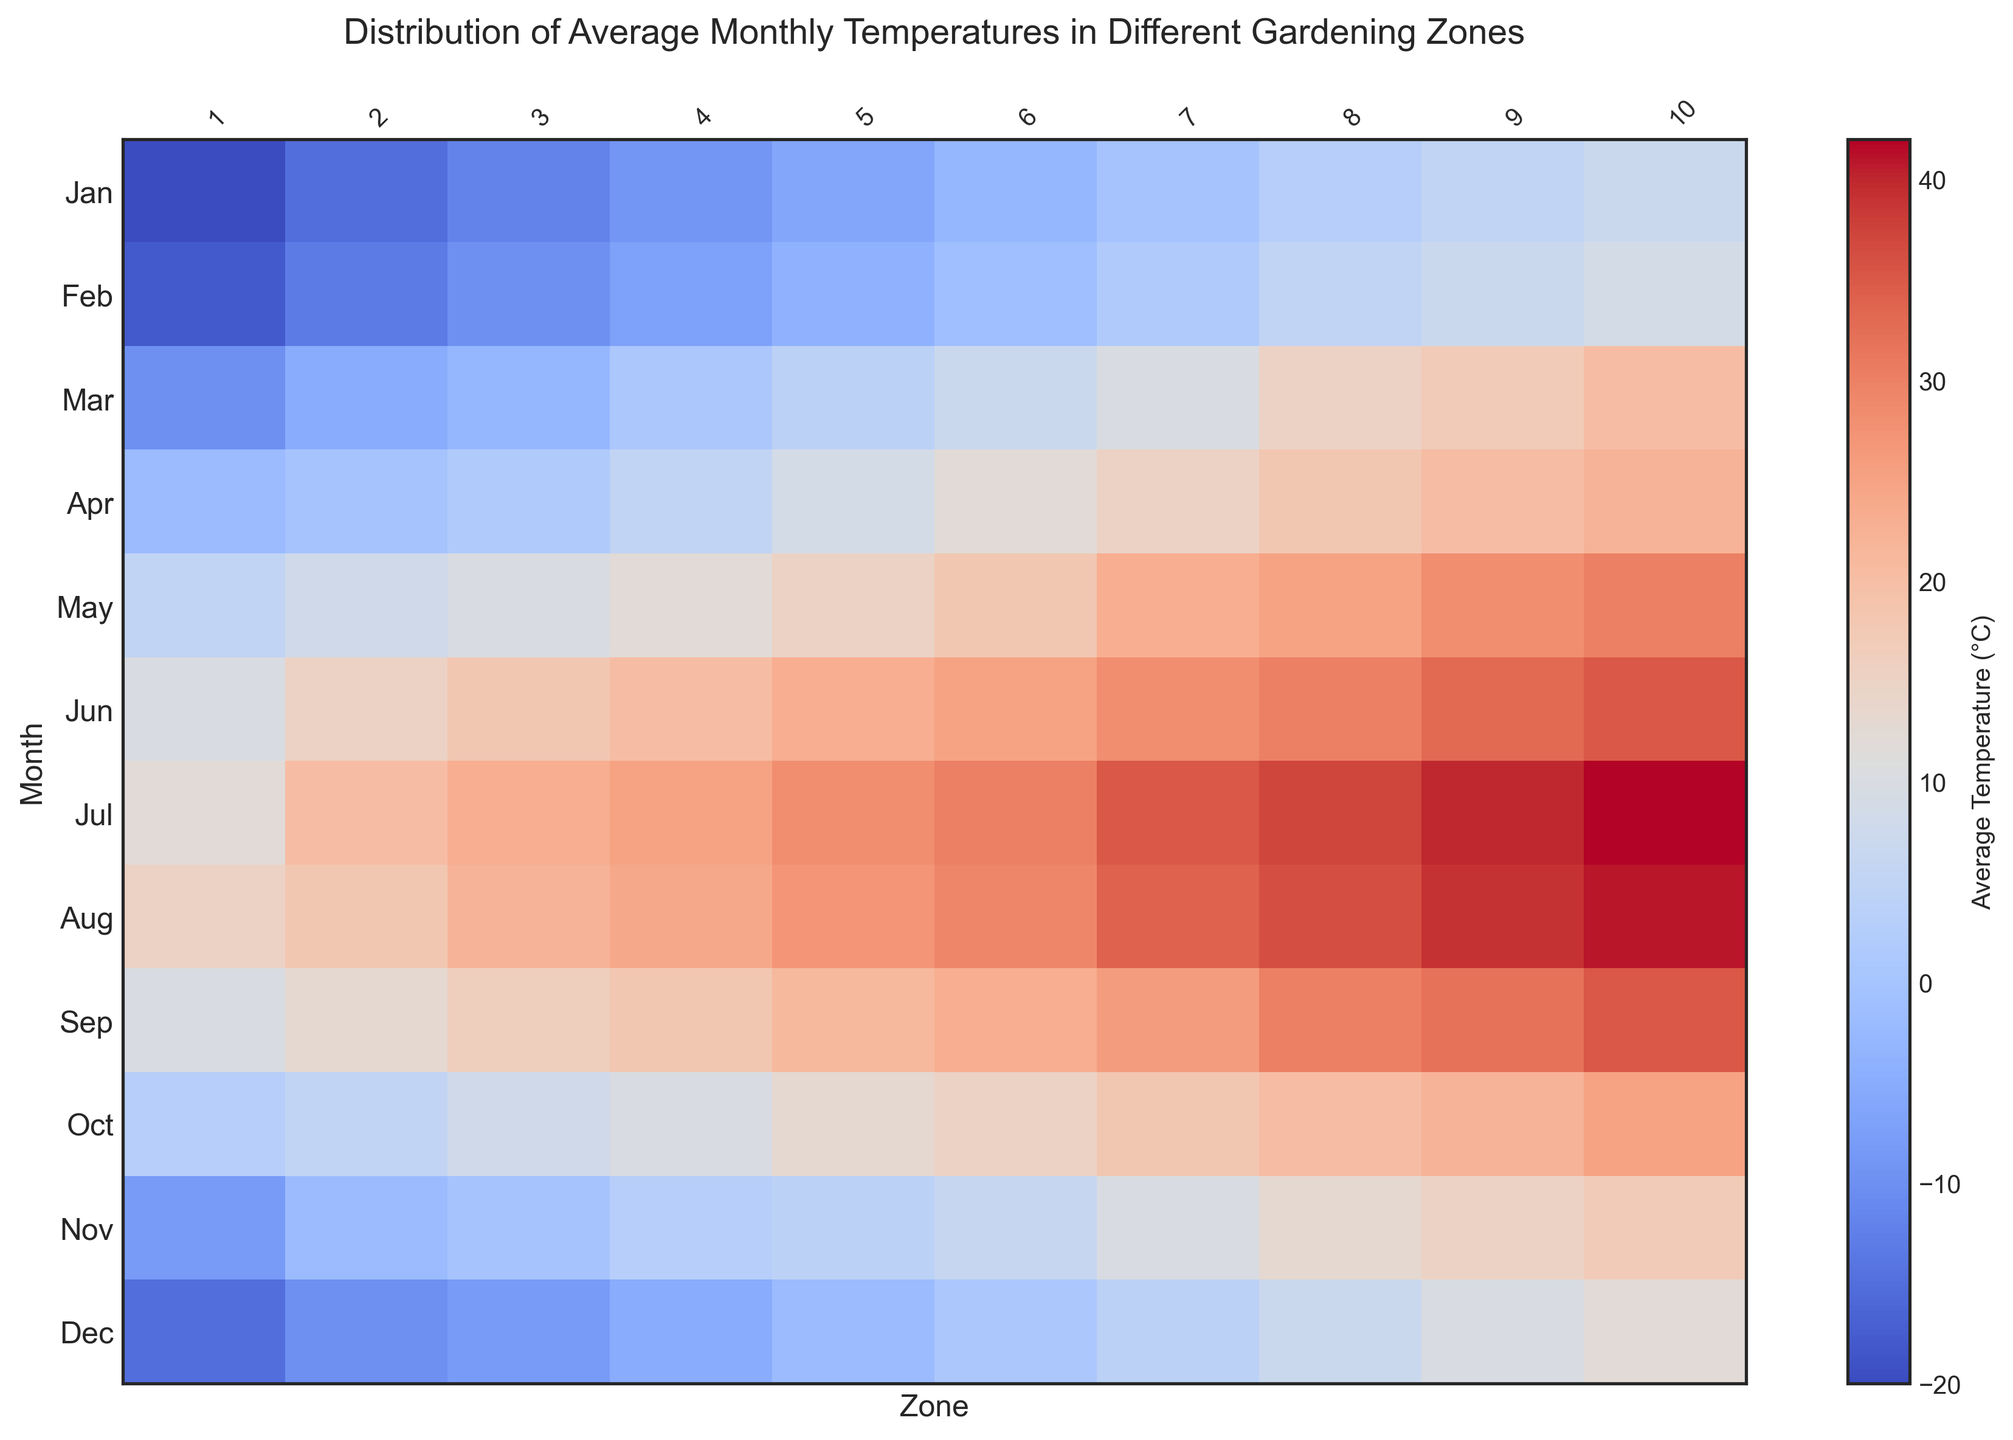What is the average temperature in Zone 5 during summer months (June, July, and August)? To calculate the average temperature for Zone 5 during the summer months, first add the temperatures for June, July, and August in Zone 5: 23 (June) + 28 (July) + 27 (August) = 78. Then, divide by the number of months, which is 3. So, 78 / 3 = 26°C.
Answer: 26°C Which Zone has the highest average temperature in January? Look for the highest value in the January row across all Zones. The values are: -20, -15, -12, -9, -6, -3, 0, 3, 5, 7. The highest value is 7 in Zone 10.
Answer: Zone 10 In which month does Zone 4 experience the largest increase in temperature? Compare the month-to-month temperature changes within Zone 4. Calculate the differences for each month: 2°C (Feb to Mar), 4°C (Mar to Apr), 7°C (Apr to May), 8°C (May to Jun), 5°C (Jun to Jul), 1°C (Jul to Aug), -6°C (Aug to Sep), -8°C (Sep to Oct), -5°C (Oct to Nov), 2°C (Nov to Dec). The largest increase of 8°C occurs from May to June.
Answer: May to June Which Zones have average temperatures above freezing (0°C) for every month? Look at each Zone's row and see which ones have all positive values. Zones 7, 8, 9, and 10 have temperatures above 0°C in every month.
Answer: Zones 7, 8, 9, and 10 How does the temperature in Zone 2 compare to Zone 3 in March? Compare the temperatures for March in Zone 2 (-5°C) and Zone 3 (-3°C). -3°C is higher than -5°C, so Zone 3 is warmer than Zone 2 in March.
Answer: Zone 3 is warmer What is the range of temperatures experienced by Zone 6 in the entire year? Find the minimum and maximum temperatures for Zone 6: -3°C (minimum in January) and 30°C (maximum in July). The range is 30 - (-3) = 33°C.
Answer: 33°C Which two consecutive months show the biggest temperature drop in Zone 8? Compare the temperature drop between each pair of consecutive months in Zone 8: Feb to Mar (+10°C), Mar to Apr (+3°C), Apr to May (+7°C), May to Jun (+5°C), Jun to Jul (+7°C), Jul to Aug (-1°C), Aug to Sep (-6°C), Sep to Oct (-10°C), Oct to Nov (-7°C), Nov to Dec (-6°C). The biggest drop of 10°C occurs from September to October.
Answer: September to October What is the average difference in temperature between Zone 9 and Zone 10 in December? Subtract the temperatures for December in Zone 9 and Zone 10: 12 - 10 = 2°C. There is no averaging needed here as it's a single month comparison.
Answer: 2°C 